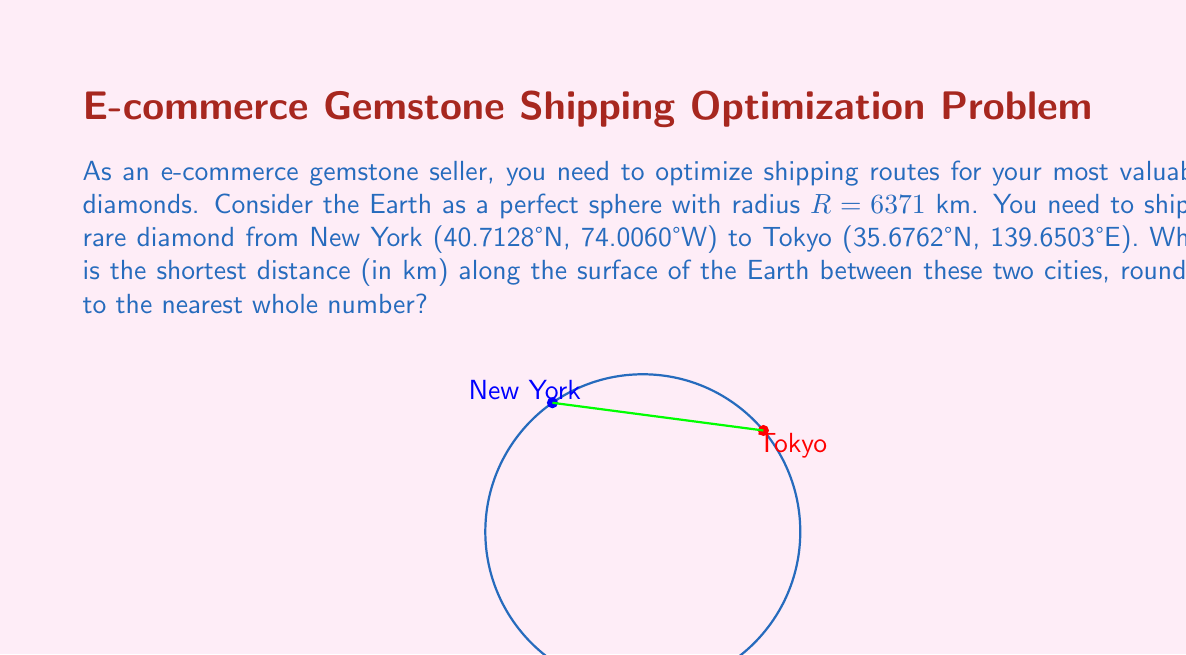Can you answer this question? To solve this problem, we'll use the concept of great circle distance, which is the shortest path between two points on a sphere. This is equivalent to finding the geodesic on a sphere.

Step 1: Convert the coordinates to radians.
New York: $\phi_1 = 40.7128° \times \frac{\pi}{180} = 0.7102$ rad, $\lambda_1 = -74.0060° \times \frac{\pi}{180} = -1.2915$ rad
Tokyo: $\phi_2 = 35.6762° \times \frac{\pi}{180} = 0.6226$ rad, $\lambda_2 = 139.6503° \times \frac{\pi}{180} = 2.4372$ rad

Step 2: Calculate the central angle $\Delta\sigma$ using the spherical law of cosines:
$$\Delta\sigma = \arccos(\sin\phi_1 \sin\phi_2 + \cos\phi_1 \cos\phi_2 \cos(\lambda_2 - \lambda_1))$$

Step 3: Substitute the values:
$$\Delta\sigma = \arccos(\sin(0.7102) \sin(0.6226) + \cos(0.7102) \cos(0.6226) \cos(2.4372 - (-1.2915)))$$
$$\Delta\sigma = \arccos(0.3533 + 0.5231 \times 0.8147) = 1.7453$$

Step 4: Calculate the great circle distance $d$:
$$d = R \times \Delta\sigma = 6371 \times 1.7453 = 11118.7 \text{ km}$$

Step 5: Round to the nearest whole number:
$$d \approx 11119 \text{ km}$$
Answer: 11119 km 